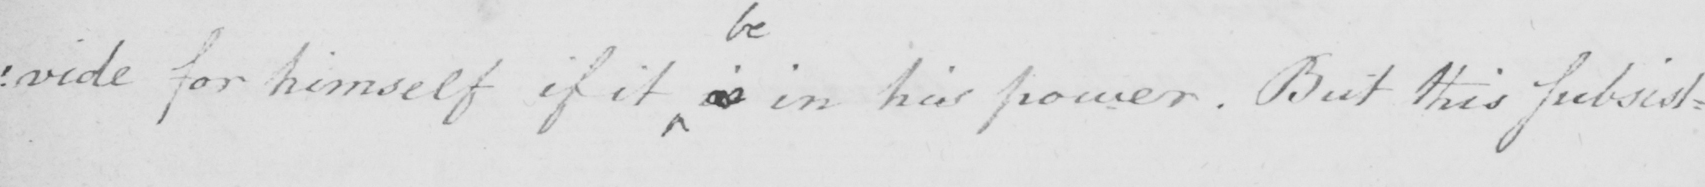What does this handwritten line say? : vide for himself if it is in his power . But this subsist : 